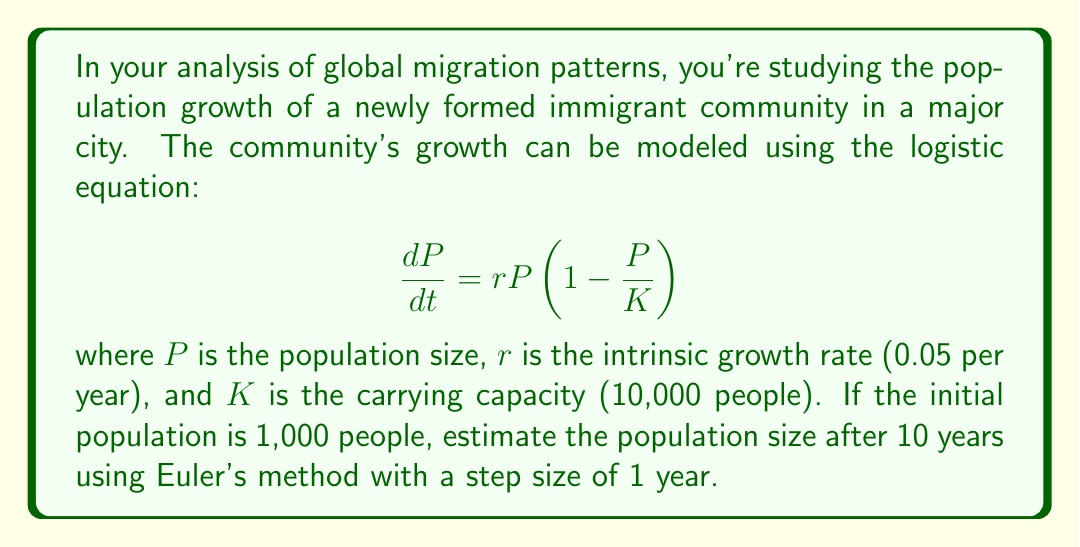Can you answer this question? To solve this problem, we'll use Euler's method to approximate the population size after 10 years. The steps are as follows:

1) Euler's method is given by the formula:
   $$P_{n+1} = P_n + h \cdot f(t_n, P_n)$$
   where $h$ is the step size, and $f(t, P) = rP(1 - \frac{P}{K})$

2) Given:
   - Initial population $P_0 = 1,000$
   - Growth rate $r = 0.05$ per year
   - Carrying capacity $K = 10,000$
   - Step size $h = 1$ year
   - Number of steps $n = 10$

3) We'll iterate 10 times, once for each year:

   For $n = 0$:
   $$P_1 = 1000 + 1 \cdot (0.05 \cdot 1000 \cdot (1 - \frac{1000}{10000})) = 1045$$

   For $n = 1$:
   $$P_2 = 1045 + 1 \cdot (0.05 \cdot 1045 \cdot (1 - \frac{1045}{10000})) = 1088.51$$

   We continue this process for the remaining 8 steps.

4) After 10 iterations, we get:
   $$P_{10} \approx 1456.22$$

Therefore, the estimated population size after 10 years is approximately 1,456 people.
Answer: 1,456 people 